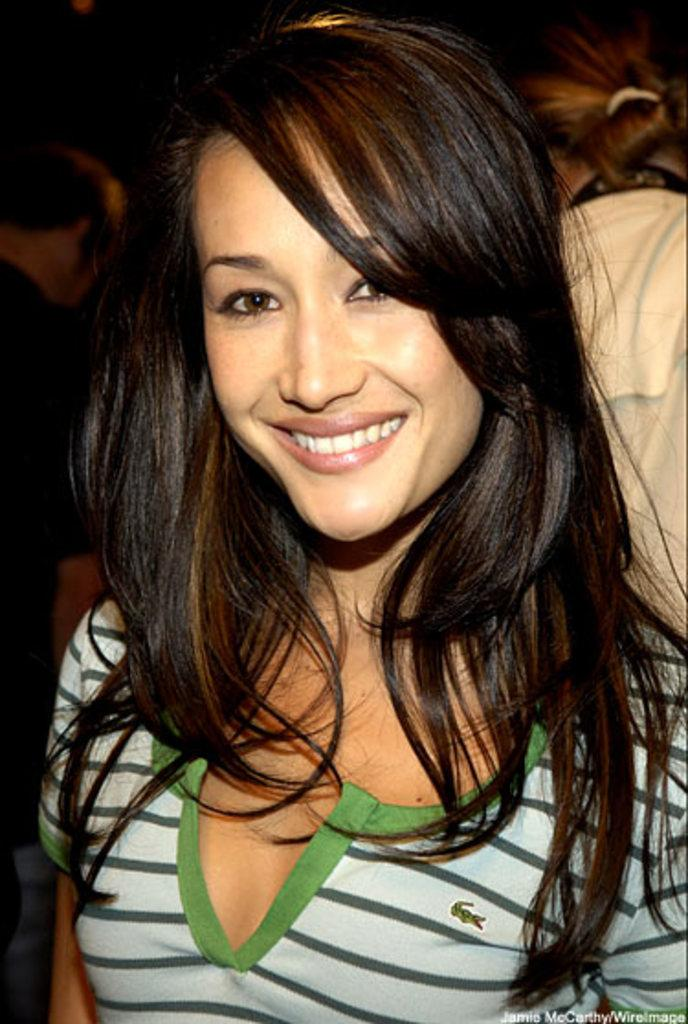Who is the main subject in the foreground of the image? There is a woman in the foreground of the image. What is the woman doing in the image? The woman is smiling. Can you describe the people in the background of the image? There are people in the background of the image, but their specific actions or expressions are not mentioned in the provided facts. What arithmetic problem are the people in the background discussing in the image? There is no information about any arithmetic problem or discussion in the image. --- 